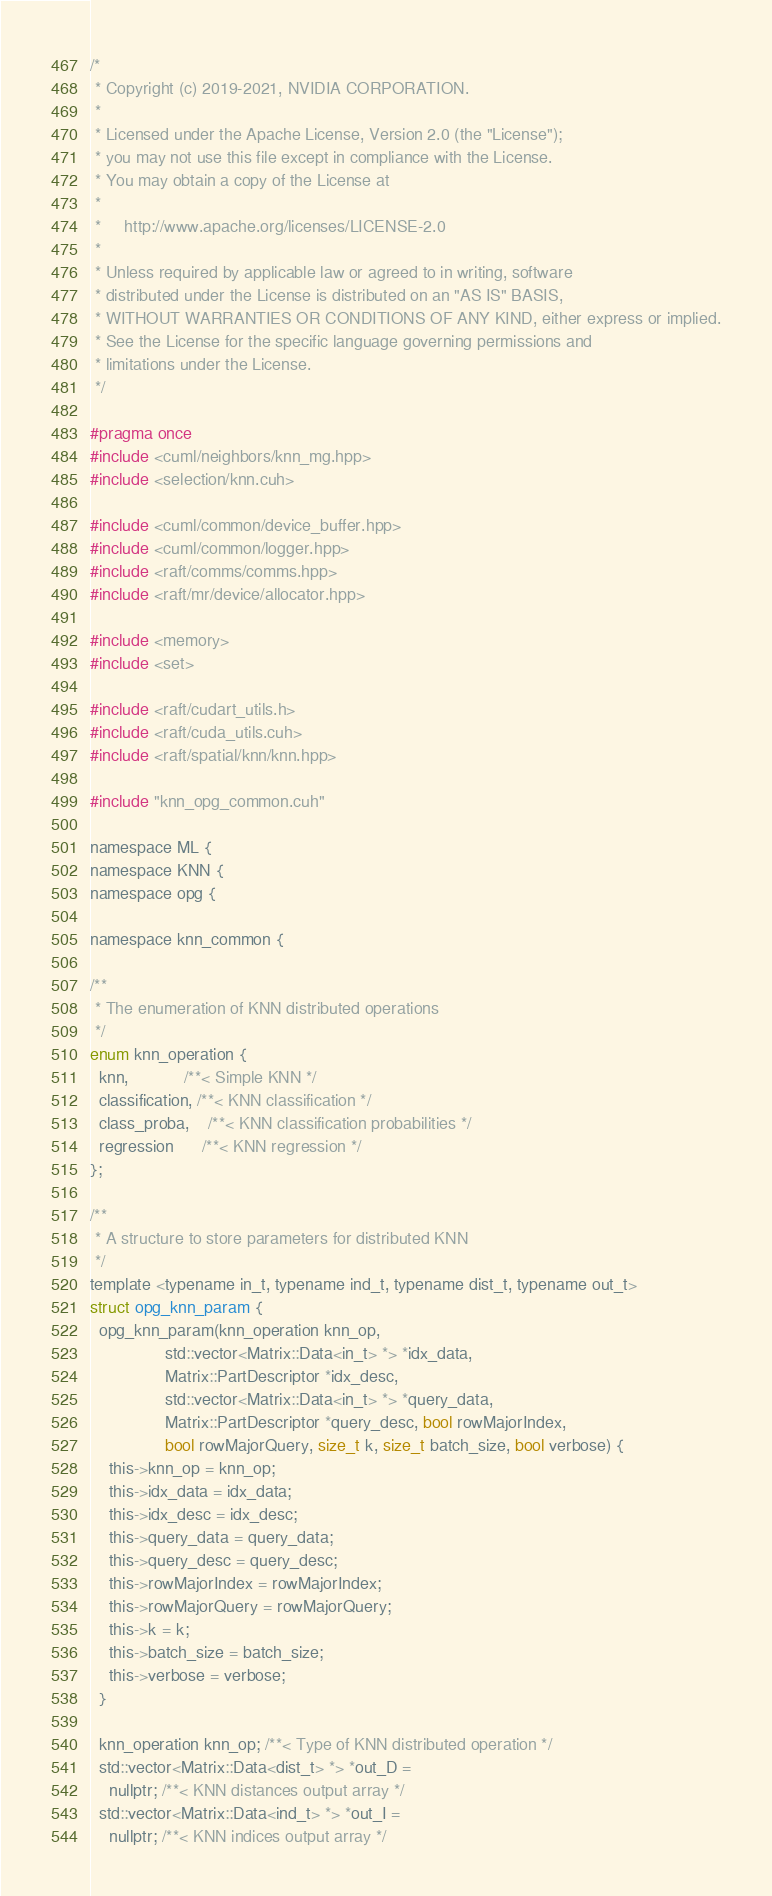Convert code to text. <code><loc_0><loc_0><loc_500><loc_500><_Cuda_>/*
 * Copyright (c) 2019-2021, NVIDIA CORPORATION.
 *
 * Licensed under the Apache License, Version 2.0 (the "License");
 * you may not use this file except in compliance with the License.
 * You may obtain a copy of the License at
 *
 *     http://www.apache.org/licenses/LICENSE-2.0
 *
 * Unless required by applicable law or agreed to in writing, software
 * distributed under the License is distributed on an "AS IS" BASIS,
 * WITHOUT WARRANTIES OR CONDITIONS OF ANY KIND, either express or implied.
 * See the License for the specific language governing permissions and
 * limitations under the License.
 */

#pragma once
#include <cuml/neighbors/knn_mg.hpp>
#include <selection/knn.cuh>

#include <cuml/common/device_buffer.hpp>
#include <cuml/common/logger.hpp>
#include <raft/comms/comms.hpp>
#include <raft/mr/device/allocator.hpp>

#include <memory>
#include <set>

#include <raft/cudart_utils.h>
#include <raft/cuda_utils.cuh>
#include <raft/spatial/knn/knn.hpp>

#include "knn_opg_common.cuh"

namespace ML {
namespace KNN {
namespace opg {

namespace knn_common {

/**
 * The enumeration of KNN distributed operations
 */
enum knn_operation {
  knn,            /**< Simple KNN */
  classification, /**< KNN classification */
  class_proba,    /**< KNN classification probabilities */
  regression      /**< KNN regression */
};

/**
 * A structure to store parameters for distributed KNN
 */
template <typename in_t, typename ind_t, typename dist_t, typename out_t>
struct opg_knn_param {
  opg_knn_param(knn_operation knn_op,
                std::vector<Matrix::Data<in_t> *> *idx_data,
                Matrix::PartDescriptor *idx_desc,
                std::vector<Matrix::Data<in_t> *> *query_data,
                Matrix::PartDescriptor *query_desc, bool rowMajorIndex,
                bool rowMajorQuery, size_t k, size_t batch_size, bool verbose) {
    this->knn_op = knn_op;
    this->idx_data = idx_data;
    this->idx_desc = idx_desc;
    this->query_data = query_data;
    this->query_desc = query_desc;
    this->rowMajorIndex = rowMajorIndex;
    this->rowMajorQuery = rowMajorQuery;
    this->k = k;
    this->batch_size = batch_size;
    this->verbose = verbose;
  }

  knn_operation knn_op; /**< Type of KNN distributed operation */
  std::vector<Matrix::Data<dist_t> *> *out_D =
    nullptr; /**< KNN distances output array */
  std::vector<Matrix::Data<ind_t> *> *out_I =
    nullptr; /**< KNN indices output array */</code> 